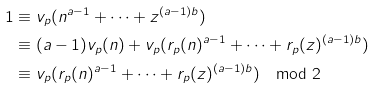Convert formula to latex. <formula><loc_0><loc_0><loc_500><loc_500>1 & \equiv v _ { p } ( n ^ { a - 1 } + \dots + z ^ { ( a - 1 ) b } ) \\ & \equiv ( a - 1 ) v _ { p } ( n ) + v _ { p } ( r _ { p } ( n ) ^ { a - 1 } + \dots + r _ { p } ( z ) ^ { ( a - 1 ) b } ) \\ & \equiv v _ { p } ( r _ { p } ( n ) ^ { a - 1 } + \dots + r _ { p } ( z ) ^ { ( a - 1 ) b } ) \mod 2</formula> 